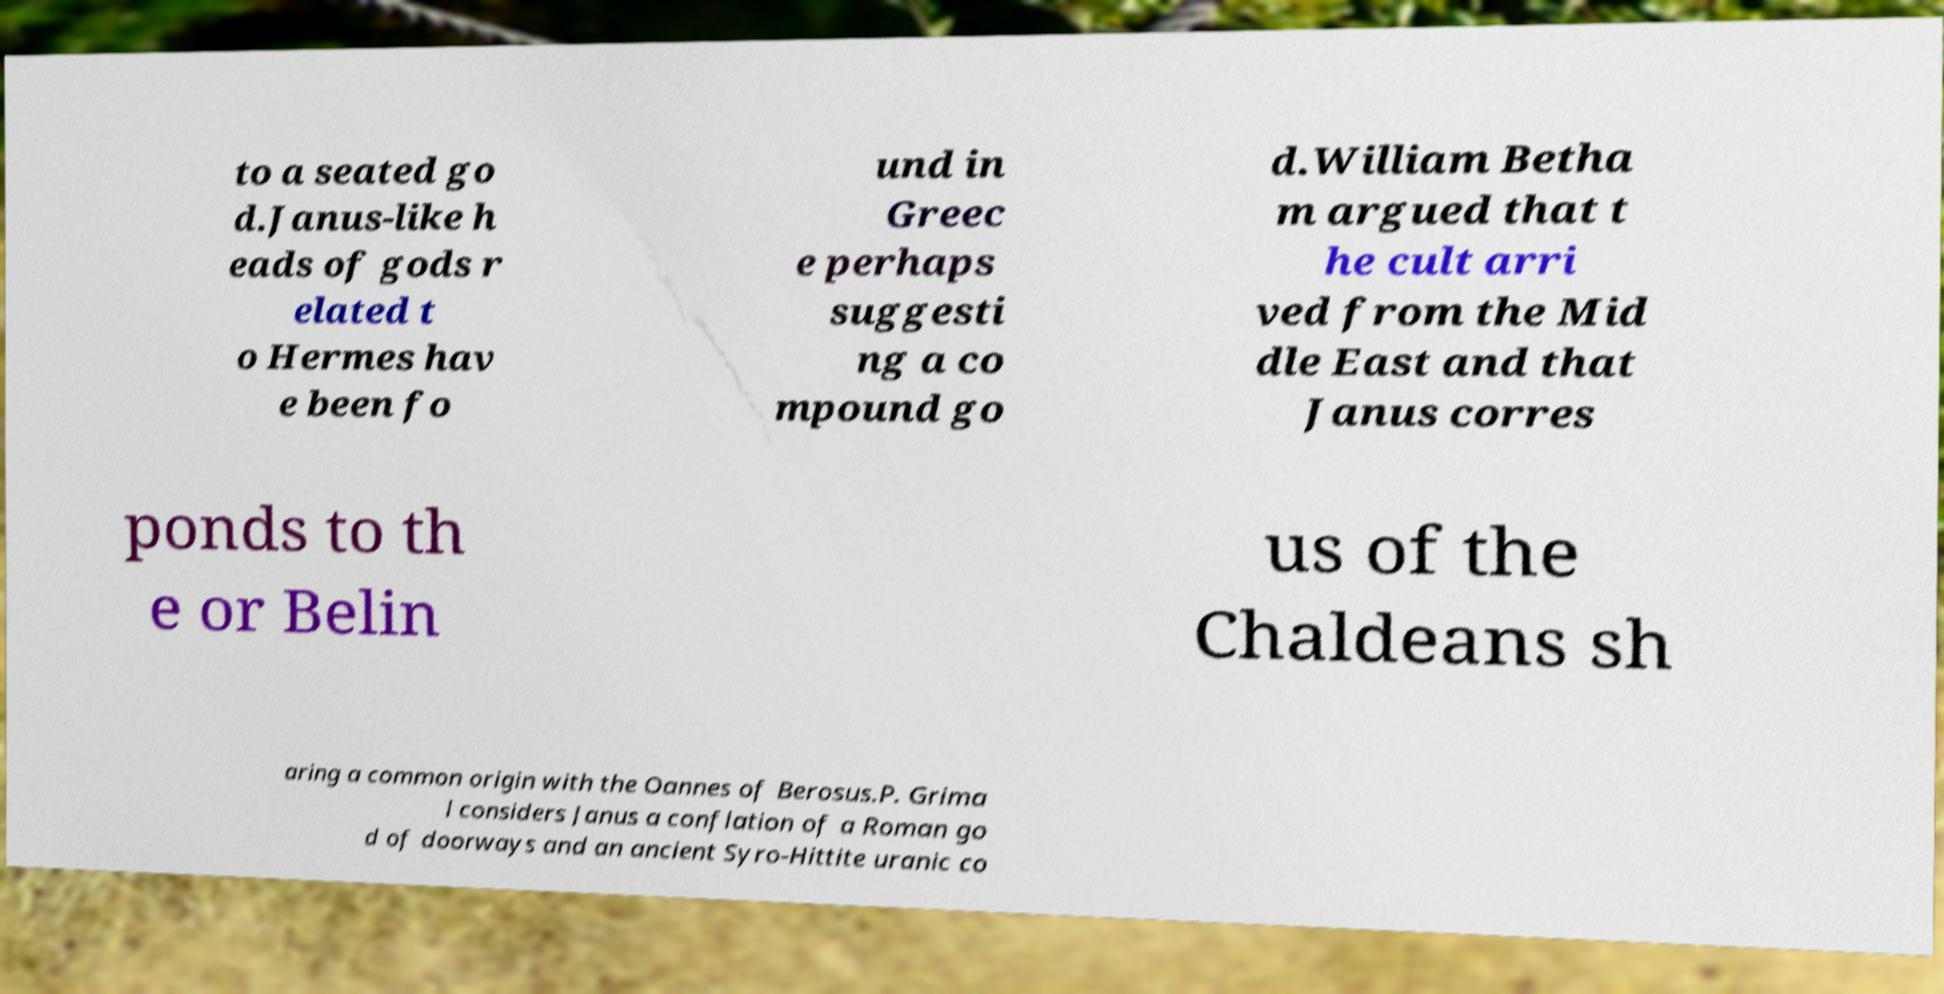Can you read and provide the text displayed in the image?This photo seems to have some interesting text. Can you extract and type it out for me? to a seated go d.Janus-like h eads of gods r elated t o Hermes hav e been fo und in Greec e perhaps suggesti ng a co mpound go d.William Betha m argued that t he cult arri ved from the Mid dle East and that Janus corres ponds to th e or Belin us of the Chaldeans sh aring a common origin with the Oannes of Berosus.P. Grima l considers Janus a conflation of a Roman go d of doorways and an ancient Syro-Hittite uranic co 